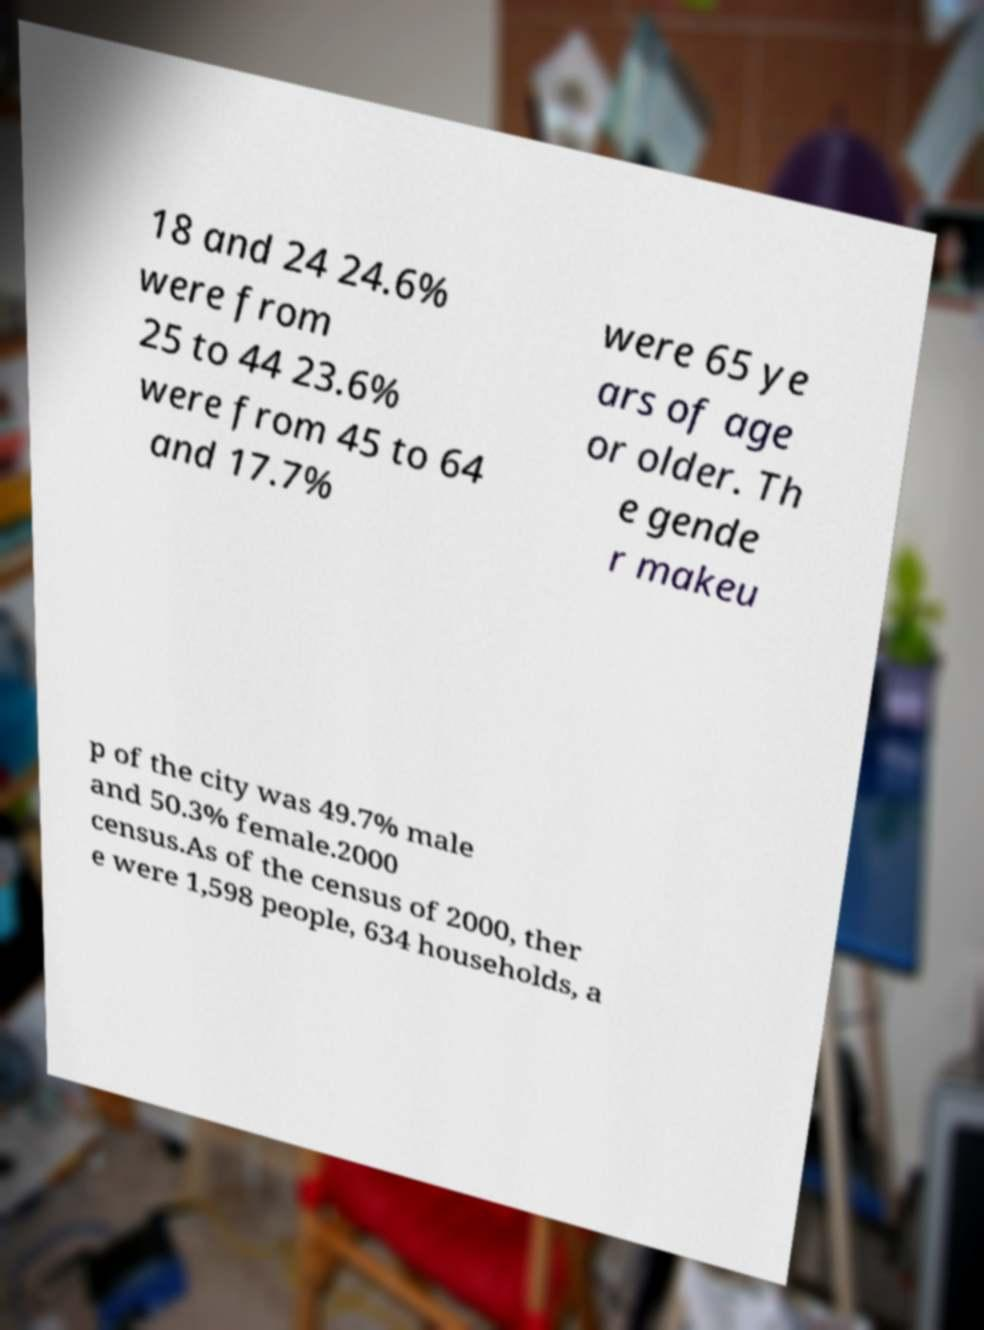Could you extract and type out the text from this image? 18 and 24 24.6% were from 25 to 44 23.6% were from 45 to 64 and 17.7% were 65 ye ars of age or older. Th e gende r makeu p of the city was 49.7% male and 50.3% female.2000 census.As of the census of 2000, ther e were 1,598 people, 634 households, a 